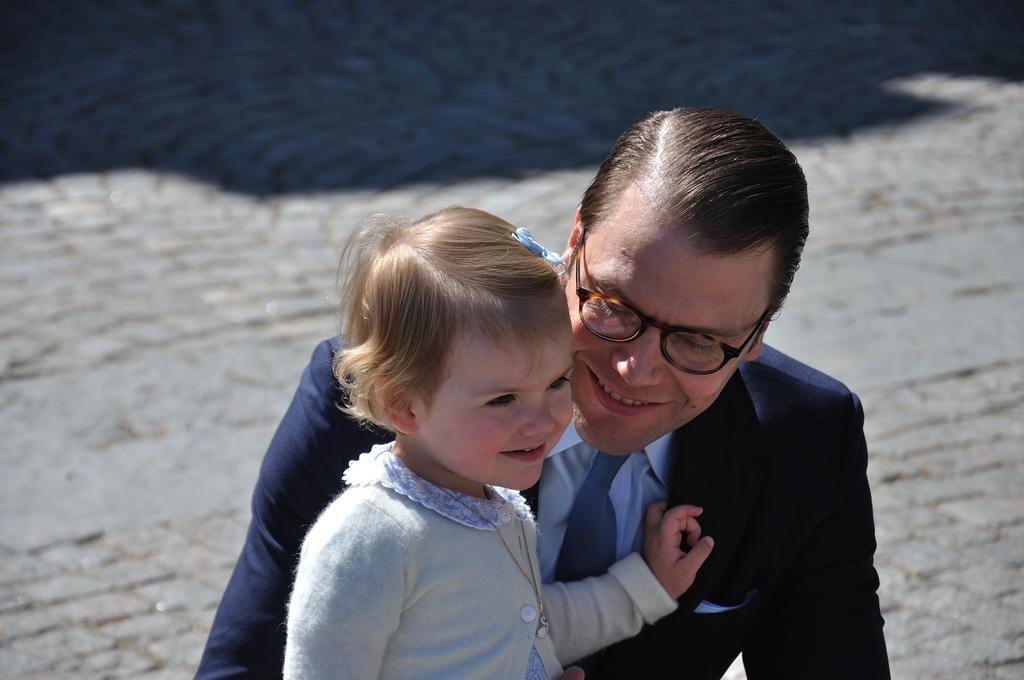How many people are in the image? There are two people in the image. Can you describe the man in the image? The man is wearing a black color jacket and spectacles. What is the girl wearing in the image? The girl is wearing a white color dress. What type of hook can be seen in the image? There is no hook present in the image. Can you provide an example of a cattle in the image? There are no cattle present in the image. 